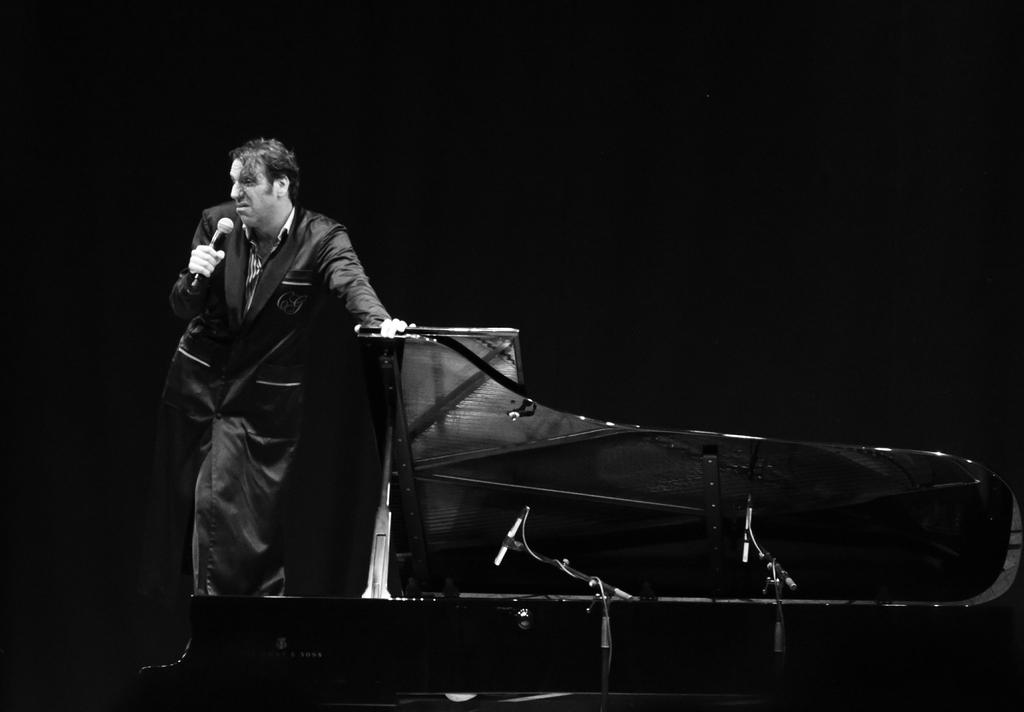What is the man in the image holding in one hand? The man is holding a mic in one hand. What is the man doing with his other hand? The man has placed his other hand on a table. What type of pies can be seen on the tray in the image? There is no tray or pies present in the image. 